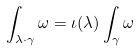Convert formula to latex. <formula><loc_0><loc_0><loc_500><loc_500>\int _ { \lambda \cdot \gamma } \omega = \iota ( \lambda ) \int _ { \gamma } \omega</formula> 